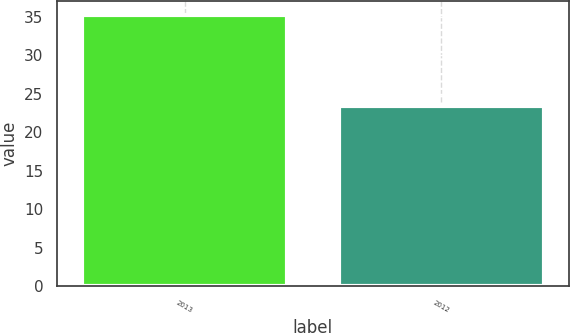Convert chart to OTSL. <chart><loc_0><loc_0><loc_500><loc_500><bar_chart><fcel>2013<fcel>2012<nl><fcel>35.25<fcel>23.44<nl></chart> 